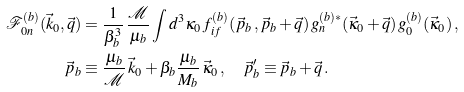Convert formula to latex. <formula><loc_0><loc_0><loc_500><loc_500>\mathcal { F } _ { 0 n } ^ { ( b ) } ( \vec { k } _ { 0 } , \vec { q } ) & = \frac { 1 } { \beta _ { b } ^ { 3 } } \, \frac { \mathcal { M } } { \mu _ { b } } \int d ^ { 3 } \kappa _ { 0 } \, f _ { i f } ^ { ( b ) } ( \vec { p } _ { b } \, , \vec { p } _ { b } + \vec { q } ) \, g _ { n } ^ { ( b ) * } ( \vec { \kappa } _ { 0 } + \vec { q } ) \, g _ { 0 } ^ { ( b ) } ( \vec { \kappa } _ { 0 } ) \, , \\ \vec { p } _ { b } & \equiv \frac { \mu _ { b } } { \mathcal { M } } \, \vec { k } _ { 0 } + \beta _ { b } \frac { \mu _ { b } } { M _ { b } } \, \vec { \kappa } _ { 0 } \, , \quad \vec { p } _ { b } ^ { \prime } \equiv \vec { p } _ { b } + \vec { q } \, .</formula> 